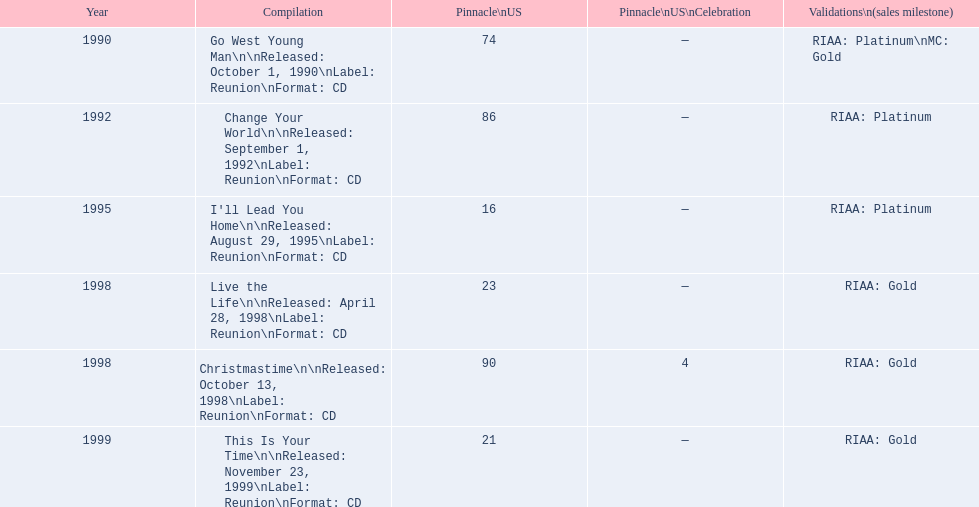Which album has the least peak in the us? I'll Lead You Home. 